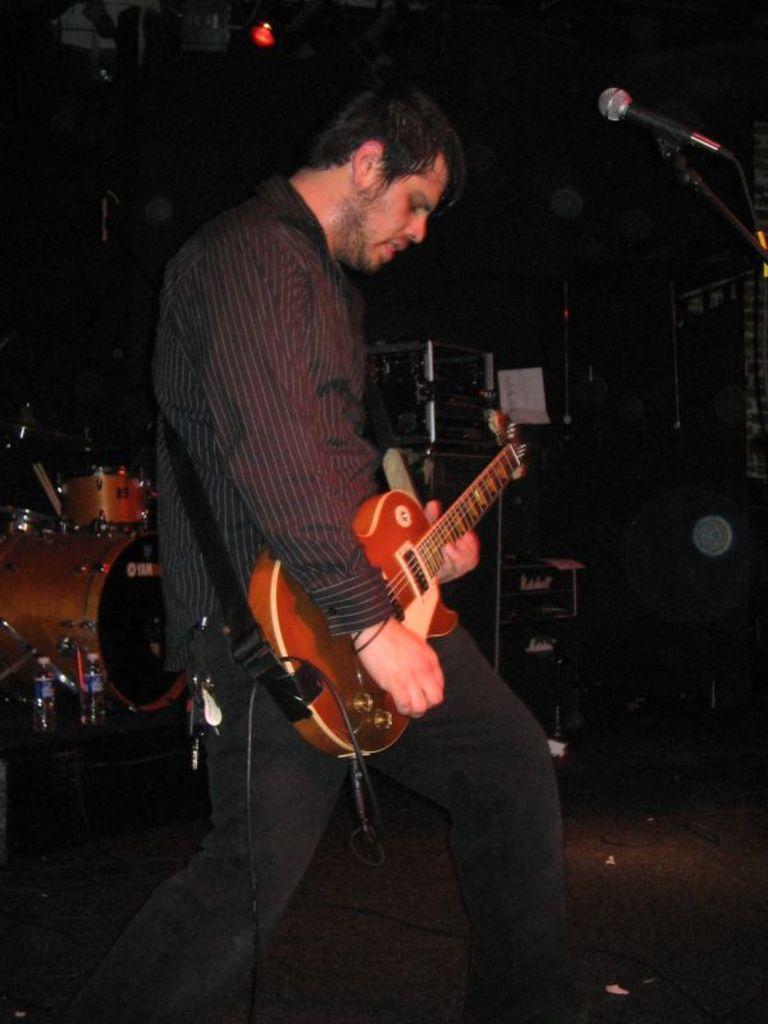Can you describe this image briefly? a person is standing playing guitar. in front of him there is a microphone. behind him at the left there are drums and water bottles. 